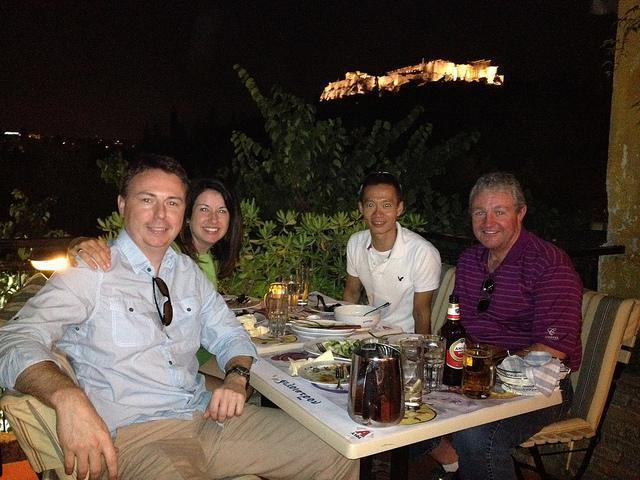How many people are there?
Give a very brief answer. 4. How many pairs of sunglasses?
Give a very brief answer. 2. How many people are in the picture?
Give a very brief answer. 4. How many people are shown?
Give a very brief answer. 4. How many people are sitting?
Give a very brief answer. 4. How many chairs are there?
Give a very brief answer. 2. How many people can you see?
Give a very brief answer. 4. 